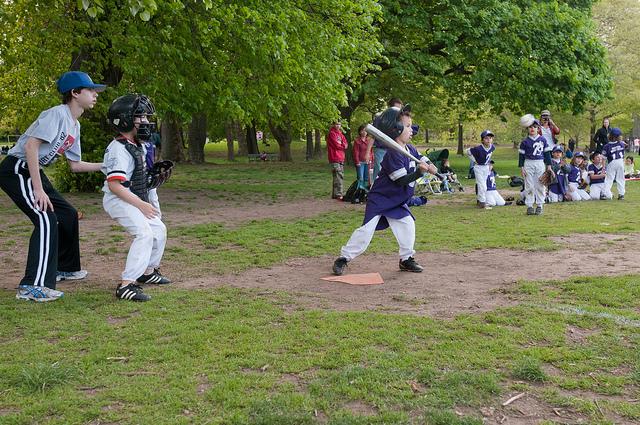Is this a soccer match?
Write a very short answer. No. Did he use a batting tee?
Quick response, please. No. What is the man closest to the picture wearing on his head?
Short answer required. Helmet. What type of event do the people appear to be attending?
Be succinct. Baseball. What sport are they playing?
Concise answer only. Baseball. What are they doing?
Be succinct. Playing baseball. What sport is being played?
Give a very brief answer. Baseball. What game are they playing?
Short answer required. Baseball. What sport is this?
Write a very short answer. Baseball. Did the boy hit the ball?
Quick response, please. Yes. What sport equipment are the boys holding?
Keep it brief. Baseball bat. What sport does this team play together?
Keep it brief. Baseball. What do we call this league?
Be succinct. Little league. Is this a MLB approved home plate?
Write a very short answer. No. What is the kid with a mask holding?
Be succinct. Glove. 